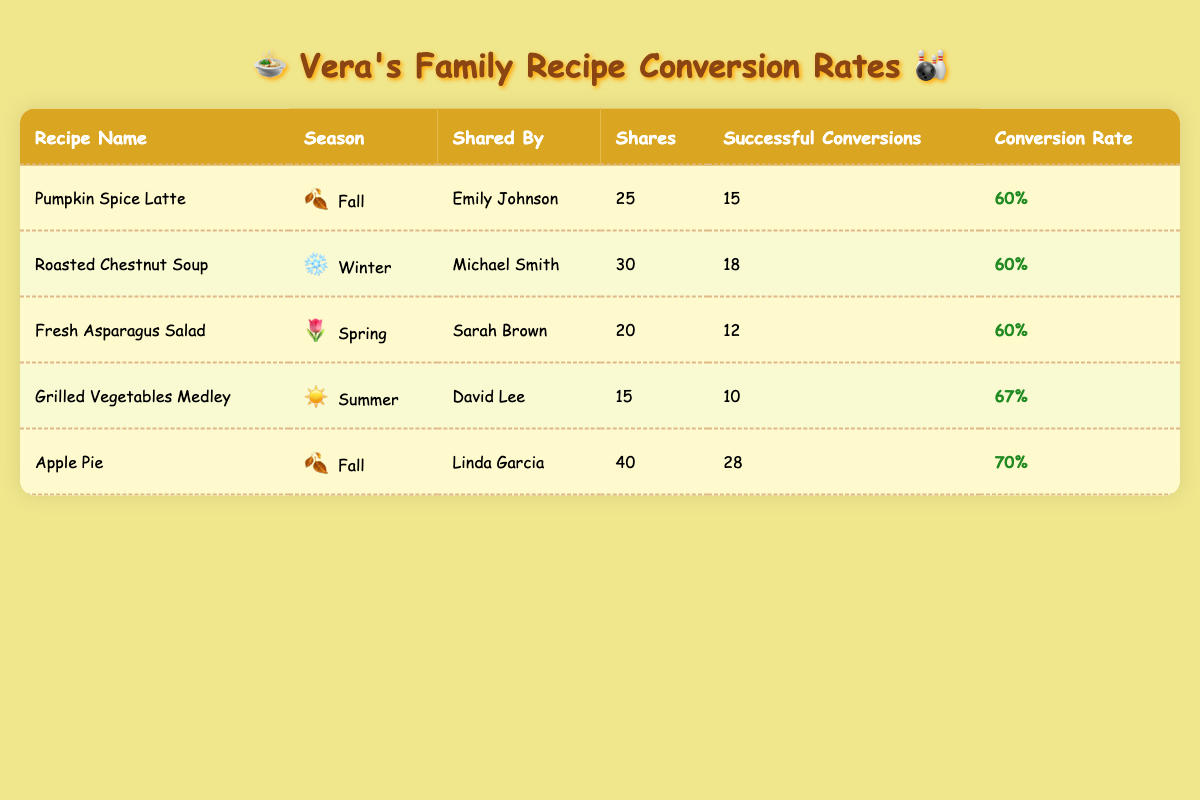What is the conversion rate for the Pumpkin Spice Latte? From the table, the conversion rate for the Pumpkin Spice Latte shared by Emily Johnson is listed as 60%.
Answer: 60% Who shared the Roasted Chestnut Soup recipe? The recipe for Roasted Chestnut Soup was shared by Michael Smith according to the table.
Answer: Michael Smith What is the total number of shares for recipes in the Fall season? To find the total shares for Fall recipes, we look for those entries: Pumpkin Spice Latte (25 shares) and Apple Pie (40 shares). Summing these gives us 25 + 40 = 65 shares in total for Fall.
Answer: 65 Is the conversion rate for Grilled Vegetables Medley higher than 60%? The conversion rate for Grilled Vegetables Medley is 67%, which is indeed higher than 60%. Therefore, the statement is true.
Answer: Yes What is the average conversion rate for all recipes listed? To calculate the average conversion rate, we add all conversion rates: 0.6 (Pumpkin Spice Latte) + 0.6 (Roasted Chestnut Soup) + 0.6 (Fresh Asparagus Salad) + 0.67 (Grilled Vegetables Medley) + 0.7 (Apple Pie) = 3.17. We divide this by the number of recipes, which is 5, giving us an average of 3.17 / 5 = 0.634 or about 63.4%.
Answer: 63.4% 